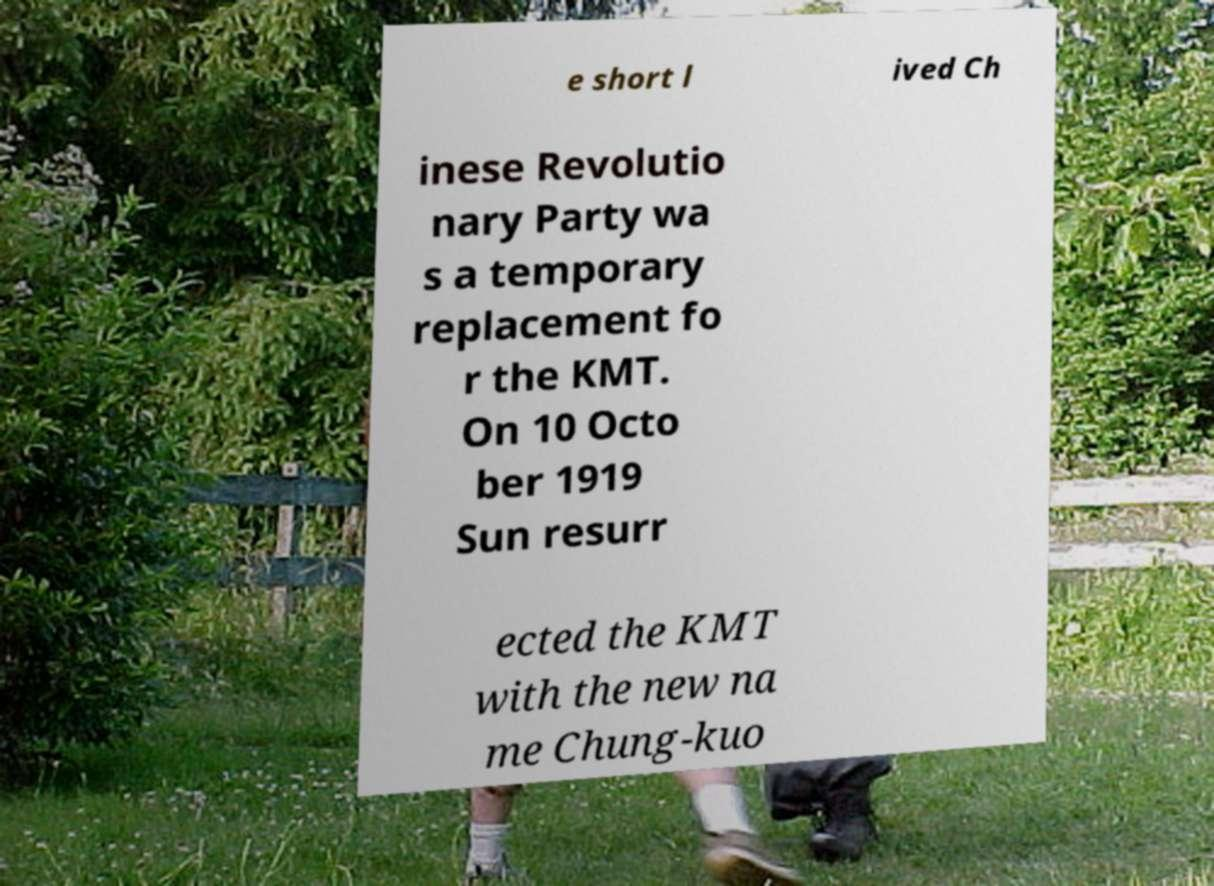Could you extract and type out the text from this image? e short l ived Ch inese Revolutio nary Party wa s a temporary replacement fo r the KMT. On 10 Octo ber 1919 Sun resurr ected the KMT with the new na me Chung-kuo 